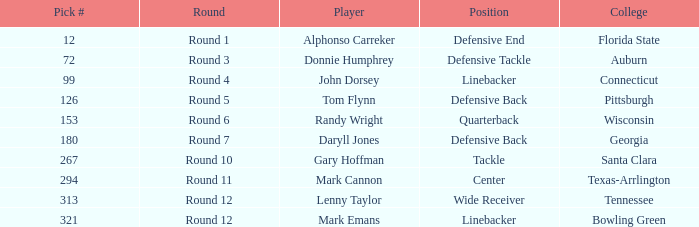What Player is a Wide Receiver? Lenny Taylor. 